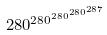Convert formula to latex. <formula><loc_0><loc_0><loc_500><loc_500>2 8 0 ^ { 2 8 0 ^ { 2 8 0 ^ { 2 8 0 ^ { 2 8 7 } } } }</formula> 